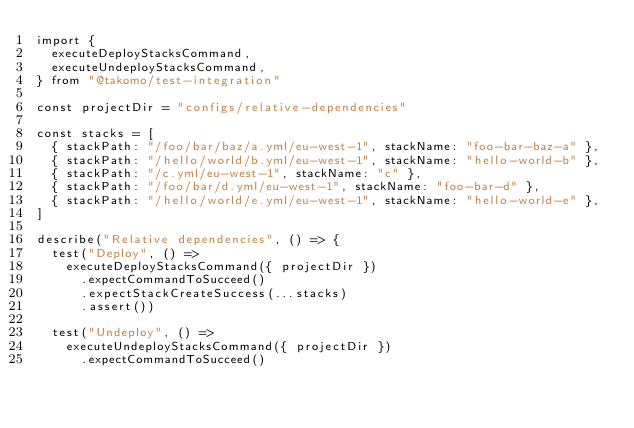Convert code to text. <code><loc_0><loc_0><loc_500><loc_500><_TypeScript_>import {
  executeDeployStacksCommand,
  executeUndeployStacksCommand,
} from "@takomo/test-integration"

const projectDir = "configs/relative-dependencies"

const stacks = [
  { stackPath: "/foo/bar/baz/a.yml/eu-west-1", stackName: "foo-bar-baz-a" },
  { stackPath: "/hello/world/b.yml/eu-west-1", stackName: "hello-world-b" },
  { stackPath: "/c.yml/eu-west-1", stackName: "c" },
  { stackPath: "/foo/bar/d.yml/eu-west-1", stackName: "foo-bar-d" },
  { stackPath: "/hello/world/e.yml/eu-west-1", stackName: "hello-world-e" },
]

describe("Relative dependencies", () => {
  test("Deploy", () =>
    executeDeployStacksCommand({ projectDir })
      .expectCommandToSucceed()
      .expectStackCreateSuccess(...stacks)
      .assert())

  test("Undeploy", () =>
    executeUndeployStacksCommand({ projectDir })
      .expectCommandToSucceed()</code> 